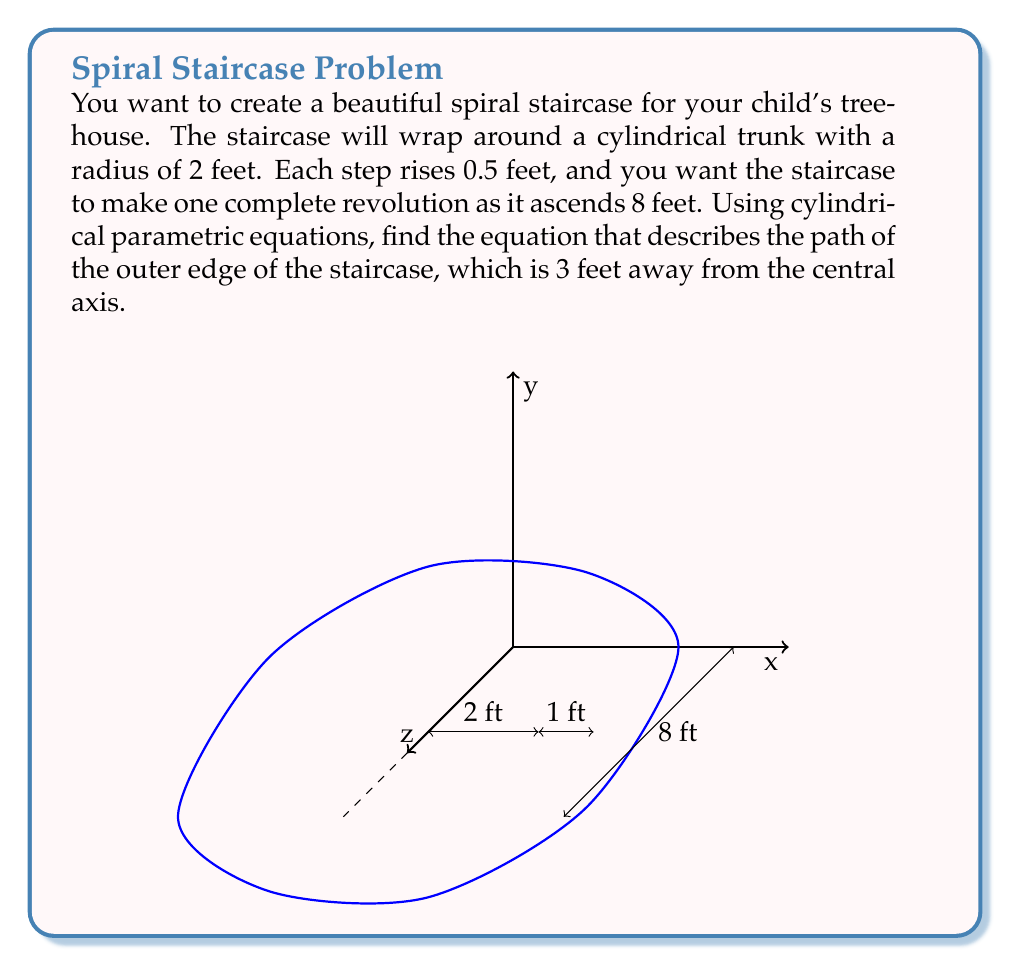Solve this math problem. Let's approach this step-by-step:

1) In cylindrical coordinates, we have:
   $x = r \cos(\theta)$
   $y = r \sin(\theta)$
   $z = z$

2) We know that:
   - The radius of the outer edge is 3 feet (r = 3)
   - One complete revolution (2π) occurs over an 8-foot rise

3) We need to relate θ and z. Since the staircase rises 0.5 feet per step and completes one revolution in 8 feet:
   $\frac{\theta}{2\pi} = \frac{z}{8}$
   
   Solving for θ: $\theta = \frac{\pi z}{4}$

4) Now we can write our parametric equations:
   $x = 3 \cos(\frac{\pi z}{4})$
   $y = 3 \sin(\frac{\pi z}{4})$
   $z = z$

5) This gives us a parametric equation in terms of z, which represents the height of the staircase.

6) To write this in standard cylindrical parametric form, we can use t as our parameter:
   $x = 3 \cos(t)$
   $y = 3 \sin(t)$
   $z = \frac{4t}{\pi}$

   Where $0 \leq t \leq 2\pi$ represents one complete revolution of the staircase.
Answer: $$x = 3 \cos(t), \quad y = 3 \sin(t), \quad z = \frac{4t}{\pi}, \quad 0 \leq t \leq 2\pi$$ 